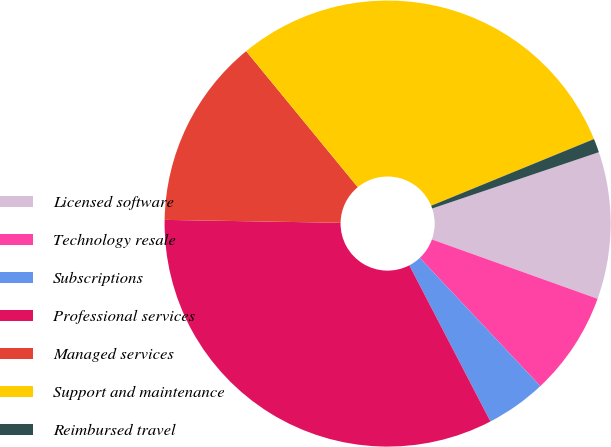Convert chart to OTSL. <chart><loc_0><loc_0><loc_500><loc_500><pie_chart><fcel>Licensed software<fcel>Technology resale<fcel>Subscriptions<fcel>Professional services<fcel>Managed services<fcel>Support and maintenance<fcel>Reimbursed travel<nl><fcel>10.66%<fcel>7.52%<fcel>4.38%<fcel>32.89%<fcel>13.8%<fcel>29.75%<fcel>1.0%<nl></chart> 